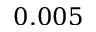<formula> <loc_0><loc_0><loc_500><loc_500>0 . 0 0 5</formula> 